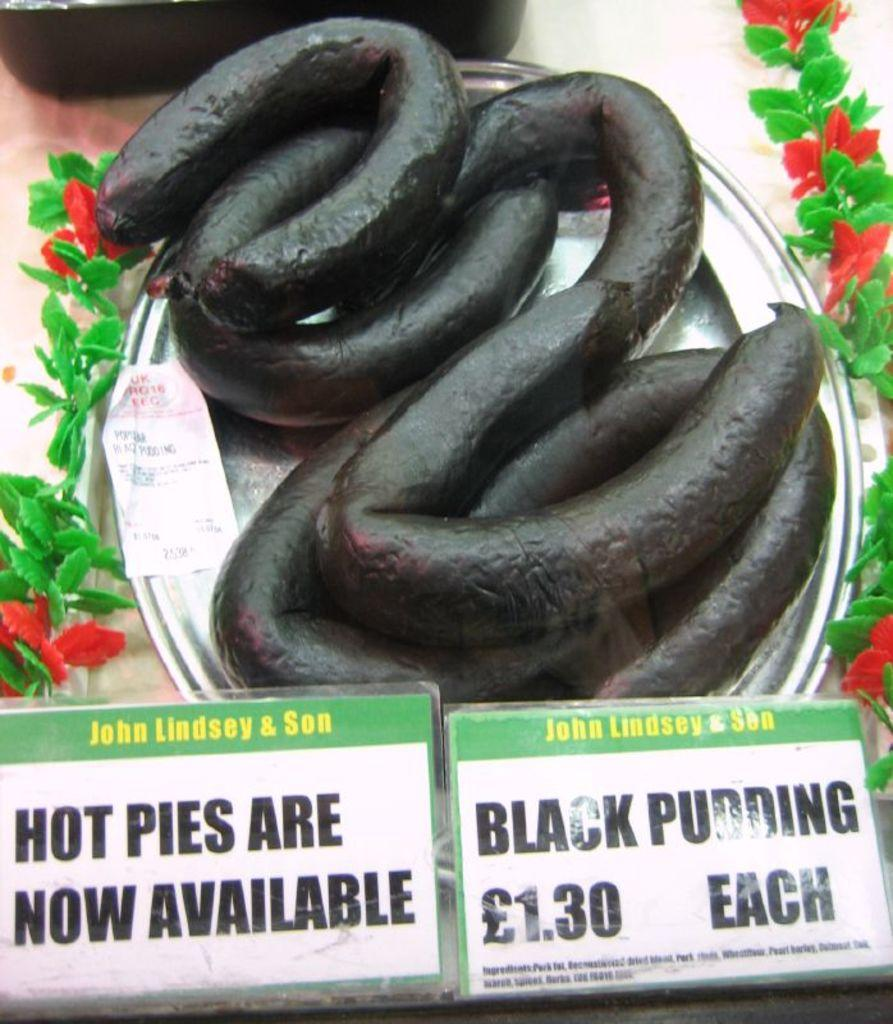What is on the plate in the image? There is a plate with black color puddings in the image. What can be seen near the plate? There is a price board near the plate. Are there any decorations in the image? Yes, there is an artificial plant and flower decoration in the image. How many planes can be seen flying in the image? There are no planes visible in the image. Is there a toothbrush included in the decoration of the image? No, there is no toothbrush present in the image. 